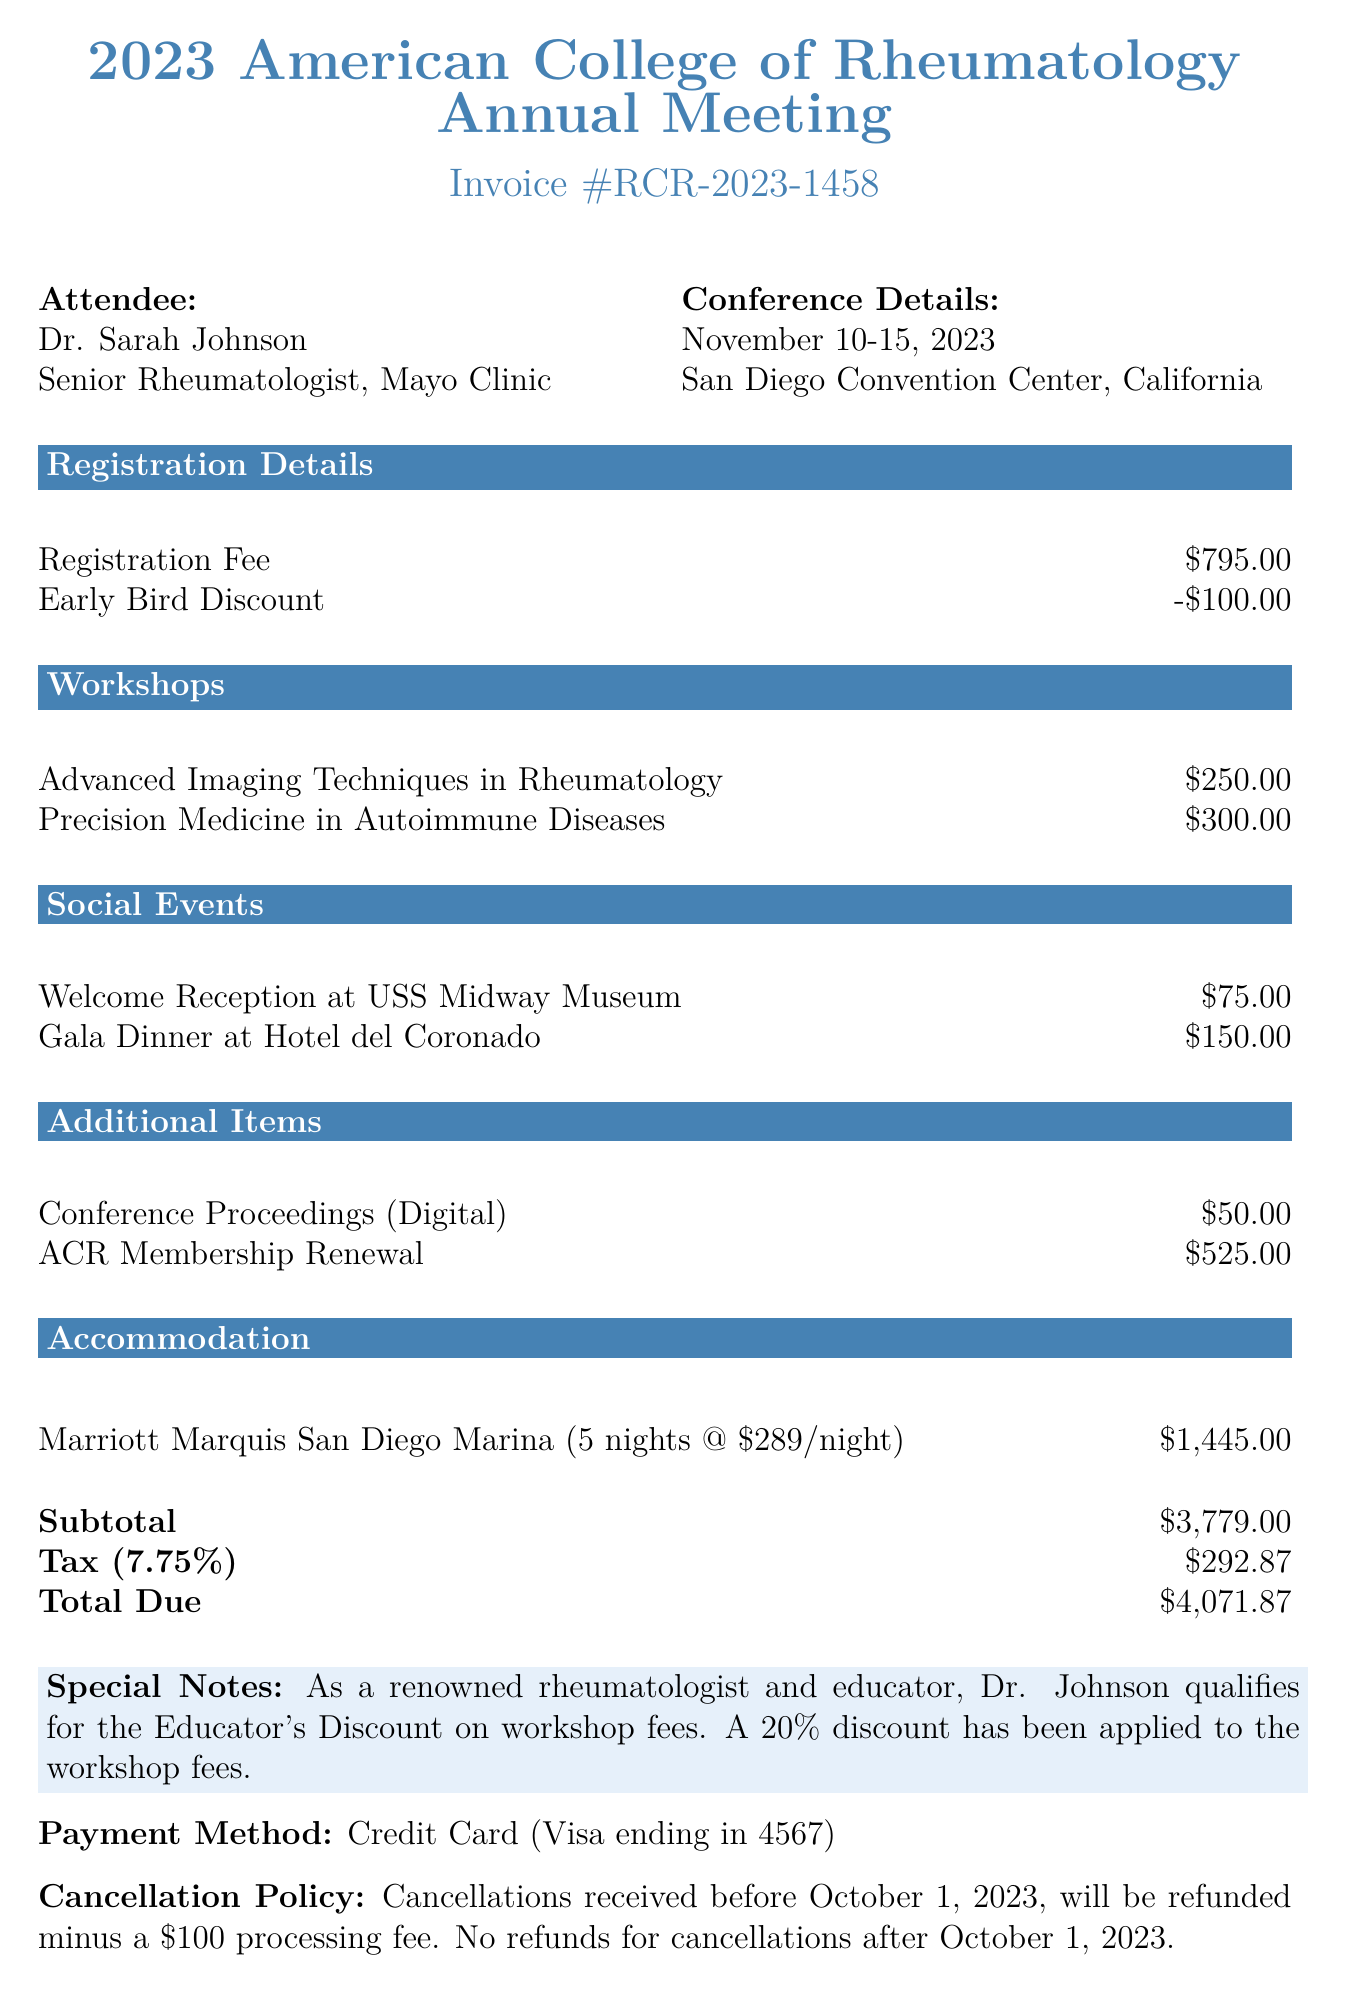What is the conference date? The conference date is specified in the document as November 10-15, 2023.
Answer: November 10-15, 2023 Who is the attendee? The attendee's name is prominently displayed in the document as Dr. Sarah Johnson.
Answer: Dr. Sarah Johnson What is the registration fee? The registration fee is listed in the document under Registration Details as $795.00.
Answer: $795.00 How much is the early bird discount? The early bird discount is mentioned in the document as -$100.00.
Answer: -$100.00 What is the total amount due? The total amount due is calculated and shown in the document as $4,071.87.
Answer: $4,071.87 How many nights is the accommodation for? The number of nights for accommodation is stated in the hotel section as 5 nights.
Answer: 5 nights What city is the conference located in? The conference location is specified in the document as San Diego, California.
Answer: San Diego, California What is the cancellation policy? The cancellation policy is summarized in the document, stating that refunds are provided for cancellations before October 1, 2023.
Answer: Refunds before October 1, 2023 What payment method was used? The payment method is given in the document as a Credit Card (Visa ending in 4567).
Answer: Credit Card (Visa ending in 4567) 